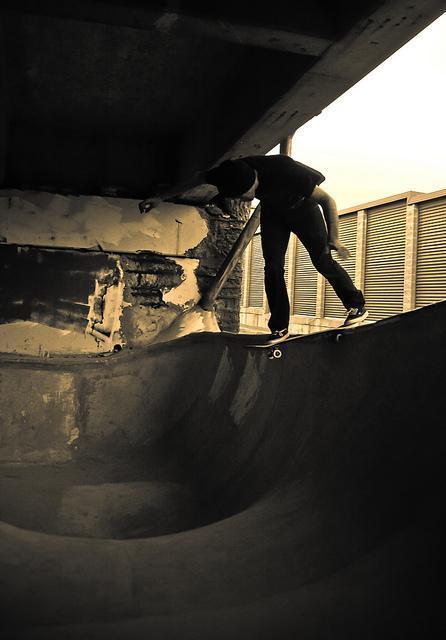How many fence panels are there?
Give a very brief answer. 5. How many giraffes are there?
Give a very brief answer. 0. 